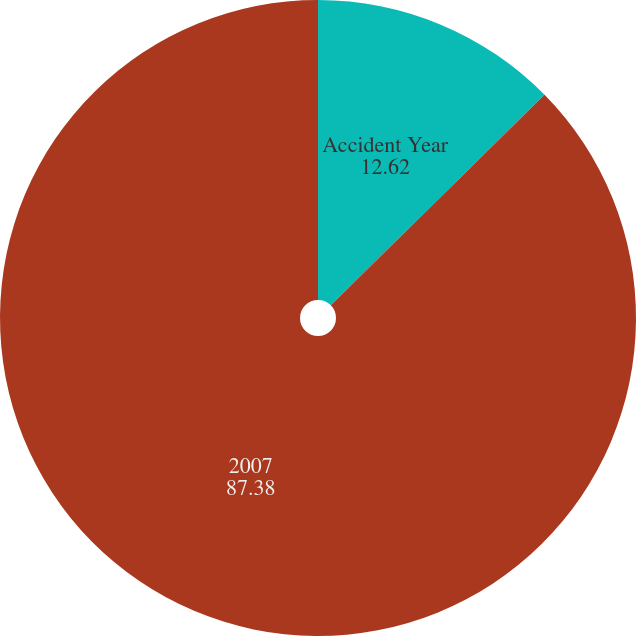Convert chart to OTSL. <chart><loc_0><loc_0><loc_500><loc_500><pie_chart><fcel>Accident Year<fcel>2007<nl><fcel>12.62%<fcel>87.38%<nl></chart> 